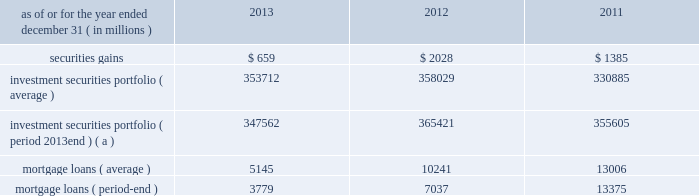Management 2019s discussion and analysis 110 jpmorgan chase & co./2013 annual report 2012 compared with 2011 net loss was $ 2.0 billion , compared with a net income of $ 919 million in the prior year .
Private equity reported net income of $ 292 million , compared with net income of $ 391 million in the prior year .
Net revenue was $ 601 million , compared with $ 836 million in the prior year , due to lower unrealized and realized gains on private investments , partially offset by higher unrealized gains on public securities .
Noninterest expense was $ 145 million , down from $ 238 million in the prior year .
Treasury and cio reported a net loss of $ 2.1 billion , compared with net income of $ 1.3 billion in the prior year .
Net revenue was a loss of $ 3.1 billion , compared with net revenue of $ 3.2 billion in the prior year .
The current year loss reflected $ 5.8 billion of losses incurred by cio from the synthetic credit portfolio for the six months ended june 30 , 2012 , and $ 449 million of losses from the retained index credit derivative positions for the three months ended september 30 , 2012 .
These losses were partially offset by securities gains of $ 2.0 billion .
The current year revenue reflected $ 888 million of extinguishment gains related to the redemption of trust preferred securities , which are included in all other income in the above table .
The extinguishment gains were related to adjustments applied to the cost basis of the trust preferred securities during the period they were in a qualified hedge accounting relationship .
Net interest income was negative $ 683 million , compared with $ 1.4 billion in the prior year , primarily reflecting the impact of lower portfolio yields and higher deposit balances across the firm .
Other corporate reported a net loss of $ 221 million , compared with a net loss of $ 821 million in the prior year .
Noninterest revenue of $ 1.8 billion was driven by a $ 1.1 billion benefit for the washington mutual bankruptcy settlement , which is included in all other income in the above table , and a $ 665 million gain from the recovery on a bear stearns-related subordinated loan .
Noninterest expense of $ 3.8 billion was up $ 1.0 billion compared with the prior year .
The current year included expense of $ 3.7 billion for additional litigation reserves , largely for mortgage-related matters .
The prior year included expense of $ 3.2 billion for additional litigation reserves .
Treasury and cio overview treasury and cio are predominantly responsible for measuring , monitoring , reporting and managing the firm 2019s liquidity , funding and structural interest rate and foreign exchange risks , as well as executing the firm 2019s capital plan .
The risks managed by treasury and cio arise from the activities undertaken by the firm 2019s four major reportable business segments to serve their respective client bases , which generate both on- and off-balance sheet assets and liabilities .
Cio achieves the firm 2019s asset-liability management objectives generally by investing in high-quality securities that are managed for the longer-term as part of the firm 2019s afs and htm investment securities portfolios ( the 201cinvestment securities portfolio 201d ) .
Cio also uses derivatives , as well as securities that are not classified as afs or htm , to meet the firm 2019s asset-liability management objectives .
For further information on derivatives , see note 6 on pages 220 2013233 of this annual report .
For further information about securities not classified within the afs or htm portfolio , see note 3 on pages 195 2013215 of this annual report .
The treasury and cio investment securities portfolio primarily consists of u.s .
And non-u.s .
Government securities , agency and non-agency mortgage-backed securities , other asset-backed securities , corporate debt securities and obligations of u.s .
States and municipalities .
At december 31 , 2013 , the total treasury and cio investment securities portfolio was $ 347.6 billion ; the average credit rating of the securities comprising the treasury and cio investment securities portfolio was aa+ ( based upon external ratings where available and where not available , based primarily upon internal ratings that correspond to ratings as defined by s&p and moody 2019s ) .
See note 12 on pages 249 2013254 of this annual report for further information on the details of the firm 2019s investment securities portfolio .
For further information on liquidity and funding risk , see liquidity risk management on pages 168 2013173 of this annual report .
For information on interest rate , foreign exchange and other risks , treasury and cio value-at-risk ( 201cvar 201d ) and the firm 2019s structural interest rate-sensitive revenue at risk , see market risk management on pages 142 2013148 of this annual report .
Selected income statement and balance sheet data as of or for the year ended december 31 , ( in millions ) 2013 2012 2011 .
( a ) period-end investment securities included held-to-maturity balance of $ 24.0 billion at december 31 , 2013 .
Held-to-maturity balances for the other periods were not material. .
Based on the selected financial statement data what was the variance between the mortgage loans average and period-end balance? 
Computations: (5145 - 3779)
Answer: 1366.0. 